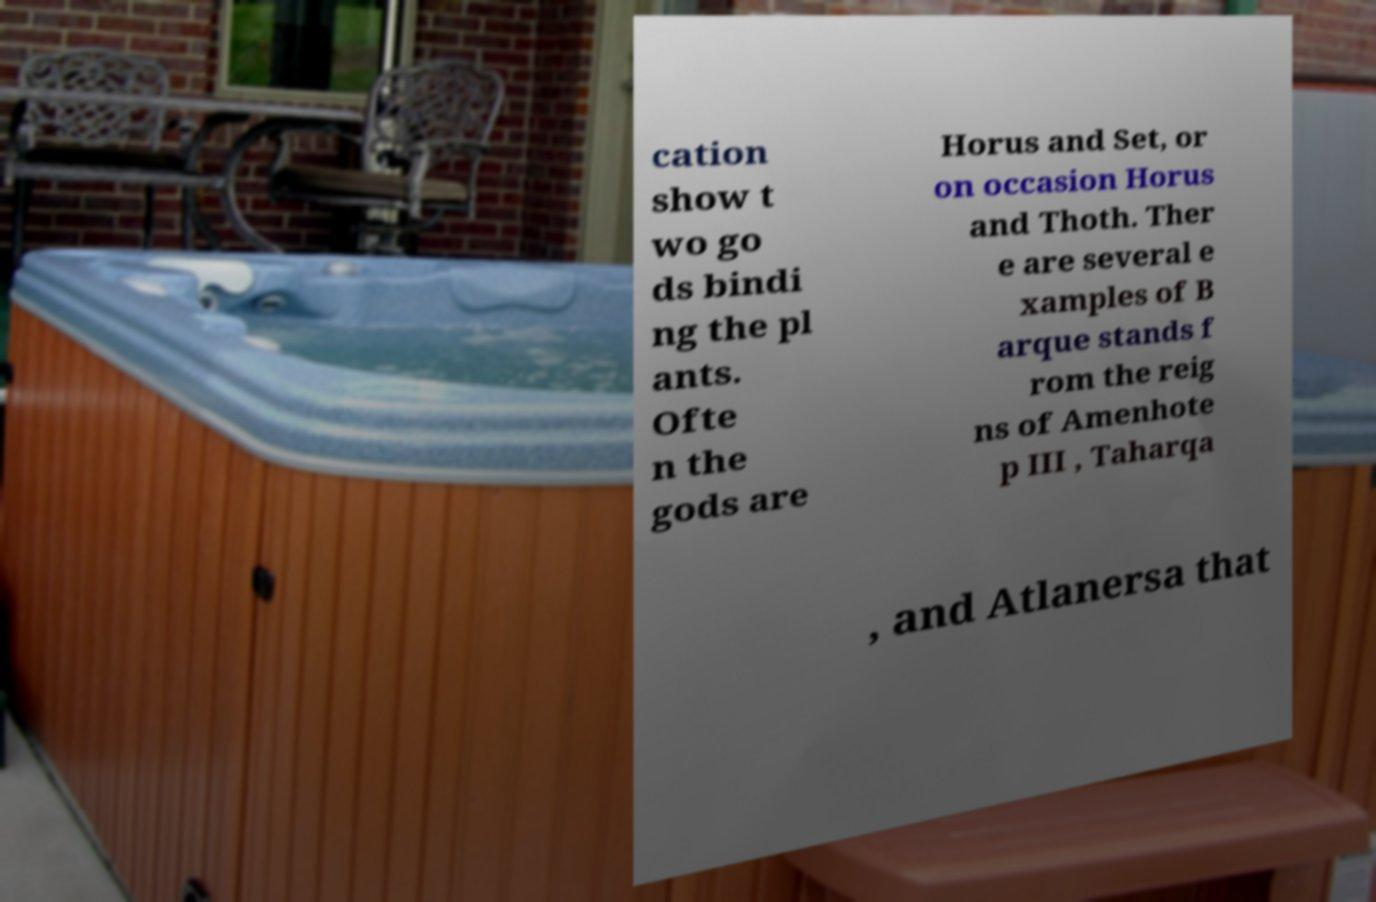I need the written content from this picture converted into text. Can you do that? cation show t wo go ds bindi ng the pl ants. Ofte n the gods are Horus and Set, or on occasion Horus and Thoth. Ther e are several e xamples of B arque stands f rom the reig ns of Amenhote p III , Taharqa , and Atlanersa that 